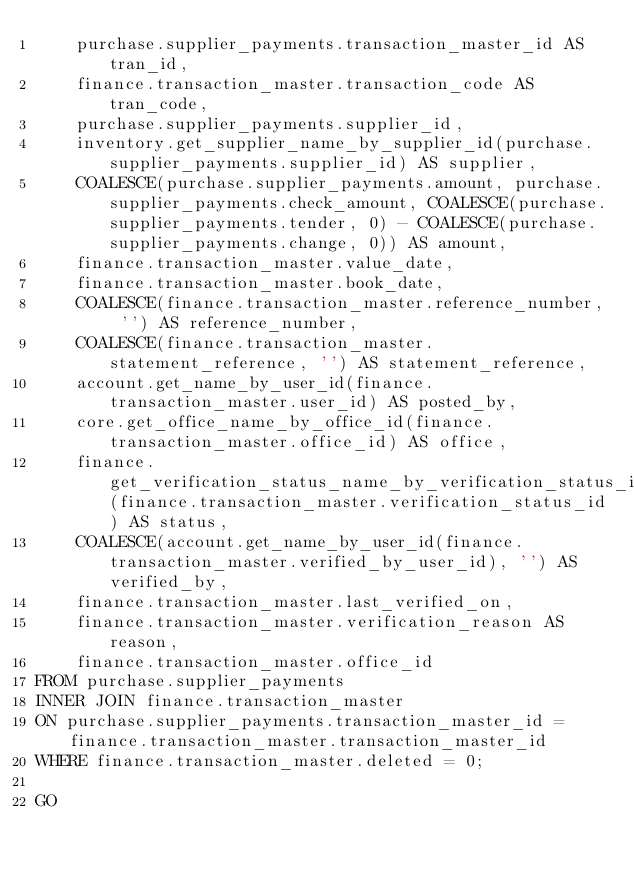Convert code to text. <code><loc_0><loc_0><loc_500><loc_500><_SQL_>	purchase.supplier_payments.transaction_master_id AS tran_id,
	finance.transaction_master.transaction_code AS tran_code,
	purchase.supplier_payments.supplier_id,
	inventory.get_supplier_name_by_supplier_id(purchase.supplier_payments.supplier_id) AS supplier,
	COALESCE(purchase.supplier_payments.amount, purchase.supplier_payments.check_amount, COALESCE(purchase.supplier_payments.tender, 0) - COALESCE(purchase.supplier_payments.change, 0)) AS amount,
	finance.transaction_master.value_date,
	finance.transaction_master.book_date,
	COALESCE(finance.transaction_master.reference_number, '') AS reference_number,
	COALESCE(finance.transaction_master.statement_reference, '') AS statement_reference,
	account.get_name_by_user_id(finance.transaction_master.user_id) AS posted_by,
	core.get_office_name_by_office_id(finance.transaction_master.office_id) AS office,
	finance.get_verification_status_name_by_verification_status_id(finance.transaction_master.verification_status_id) AS status,
	COALESCE(account.get_name_by_user_id(finance.transaction_master.verified_by_user_id), '') AS verified_by,
	finance.transaction_master.last_verified_on,
	finance.transaction_master.verification_reason AS reason,
	finance.transaction_master.office_id
FROM purchase.supplier_payments
INNER JOIN finance.transaction_master
ON purchase.supplier_payments.transaction_master_id = finance.transaction_master.transaction_master_id
WHERE finance.transaction_master.deleted = 0;

GO

</code> 